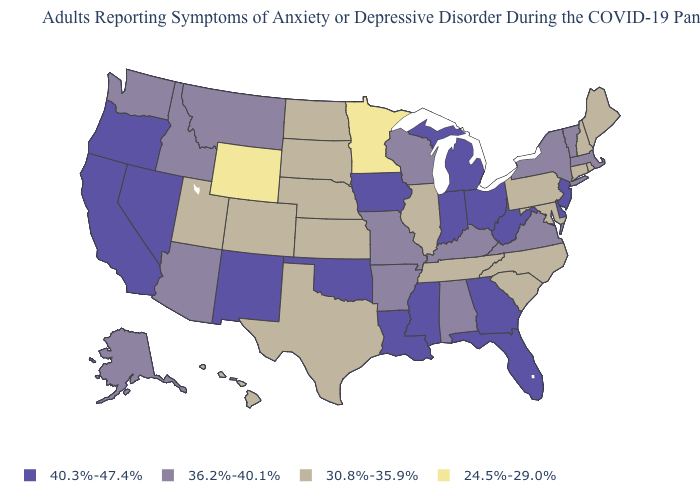Name the states that have a value in the range 40.3%-47.4%?
Write a very short answer. California, Delaware, Florida, Georgia, Indiana, Iowa, Louisiana, Michigan, Mississippi, Nevada, New Jersey, New Mexico, Ohio, Oklahoma, Oregon, West Virginia. What is the value of Florida?
Concise answer only. 40.3%-47.4%. What is the value of Massachusetts?
Give a very brief answer. 36.2%-40.1%. Which states hav the highest value in the MidWest?
Be succinct. Indiana, Iowa, Michigan, Ohio. Among the states that border Minnesota , does Iowa have the lowest value?
Write a very short answer. No. What is the highest value in states that border Texas?
Quick response, please. 40.3%-47.4%. What is the lowest value in the MidWest?
Write a very short answer. 24.5%-29.0%. Name the states that have a value in the range 30.8%-35.9%?
Concise answer only. Colorado, Connecticut, Hawaii, Illinois, Kansas, Maine, Maryland, Nebraska, New Hampshire, North Carolina, North Dakota, Pennsylvania, Rhode Island, South Carolina, South Dakota, Tennessee, Texas, Utah. How many symbols are there in the legend?
Write a very short answer. 4. Name the states that have a value in the range 36.2%-40.1%?
Answer briefly. Alabama, Alaska, Arizona, Arkansas, Idaho, Kentucky, Massachusetts, Missouri, Montana, New York, Vermont, Virginia, Washington, Wisconsin. Name the states that have a value in the range 30.8%-35.9%?
Give a very brief answer. Colorado, Connecticut, Hawaii, Illinois, Kansas, Maine, Maryland, Nebraska, New Hampshire, North Carolina, North Dakota, Pennsylvania, Rhode Island, South Carolina, South Dakota, Tennessee, Texas, Utah. What is the highest value in states that border Nebraska?
Keep it brief. 40.3%-47.4%. Among the states that border North Dakota , which have the lowest value?
Short answer required. Minnesota. Does Wyoming have the lowest value in the USA?
Answer briefly. Yes. What is the lowest value in the MidWest?
Concise answer only. 24.5%-29.0%. 